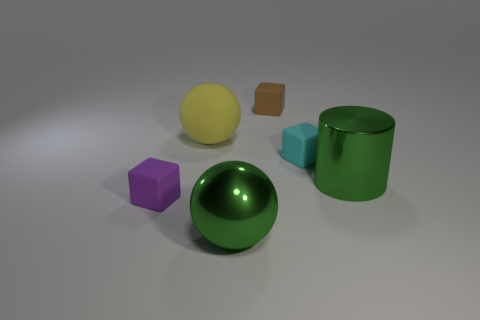There is a cyan thing that is the same shape as the brown matte thing; what is its material?
Make the answer very short. Rubber. What number of cubes are in front of the big metallic thing on the right side of the small block behind the large yellow object?
Keep it short and to the point. 1. Is there anything else that has the same color as the large matte thing?
Offer a terse response. No. What number of objects are on the left side of the cyan object and right of the metallic sphere?
Provide a short and direct response. 1. There is a ball behind the big green metallic cylinder; is it the same size as the matte block on the right side of the tiny brown thing?
Offer a very short reply. No. What number of objects are either things that are in front of the big yellow rubber ball or cyan rubber objects?
Provide a short and direct response. 4. There is a large green object that is on the right side of the brown cube; what is it made of?
Provide a short and direct response. Metal. What material is the big cylinder?
Provide a short and direct response. Metal. The green object on the right side of the ball that is in front of the ball behind the tiny cyan matte thing is made of what material?
Ensure brevity in your answer.  Metal. Does the green cylinder have the same size as the cube in front of the tiny cyan block?
Offer a very short reply. No. 